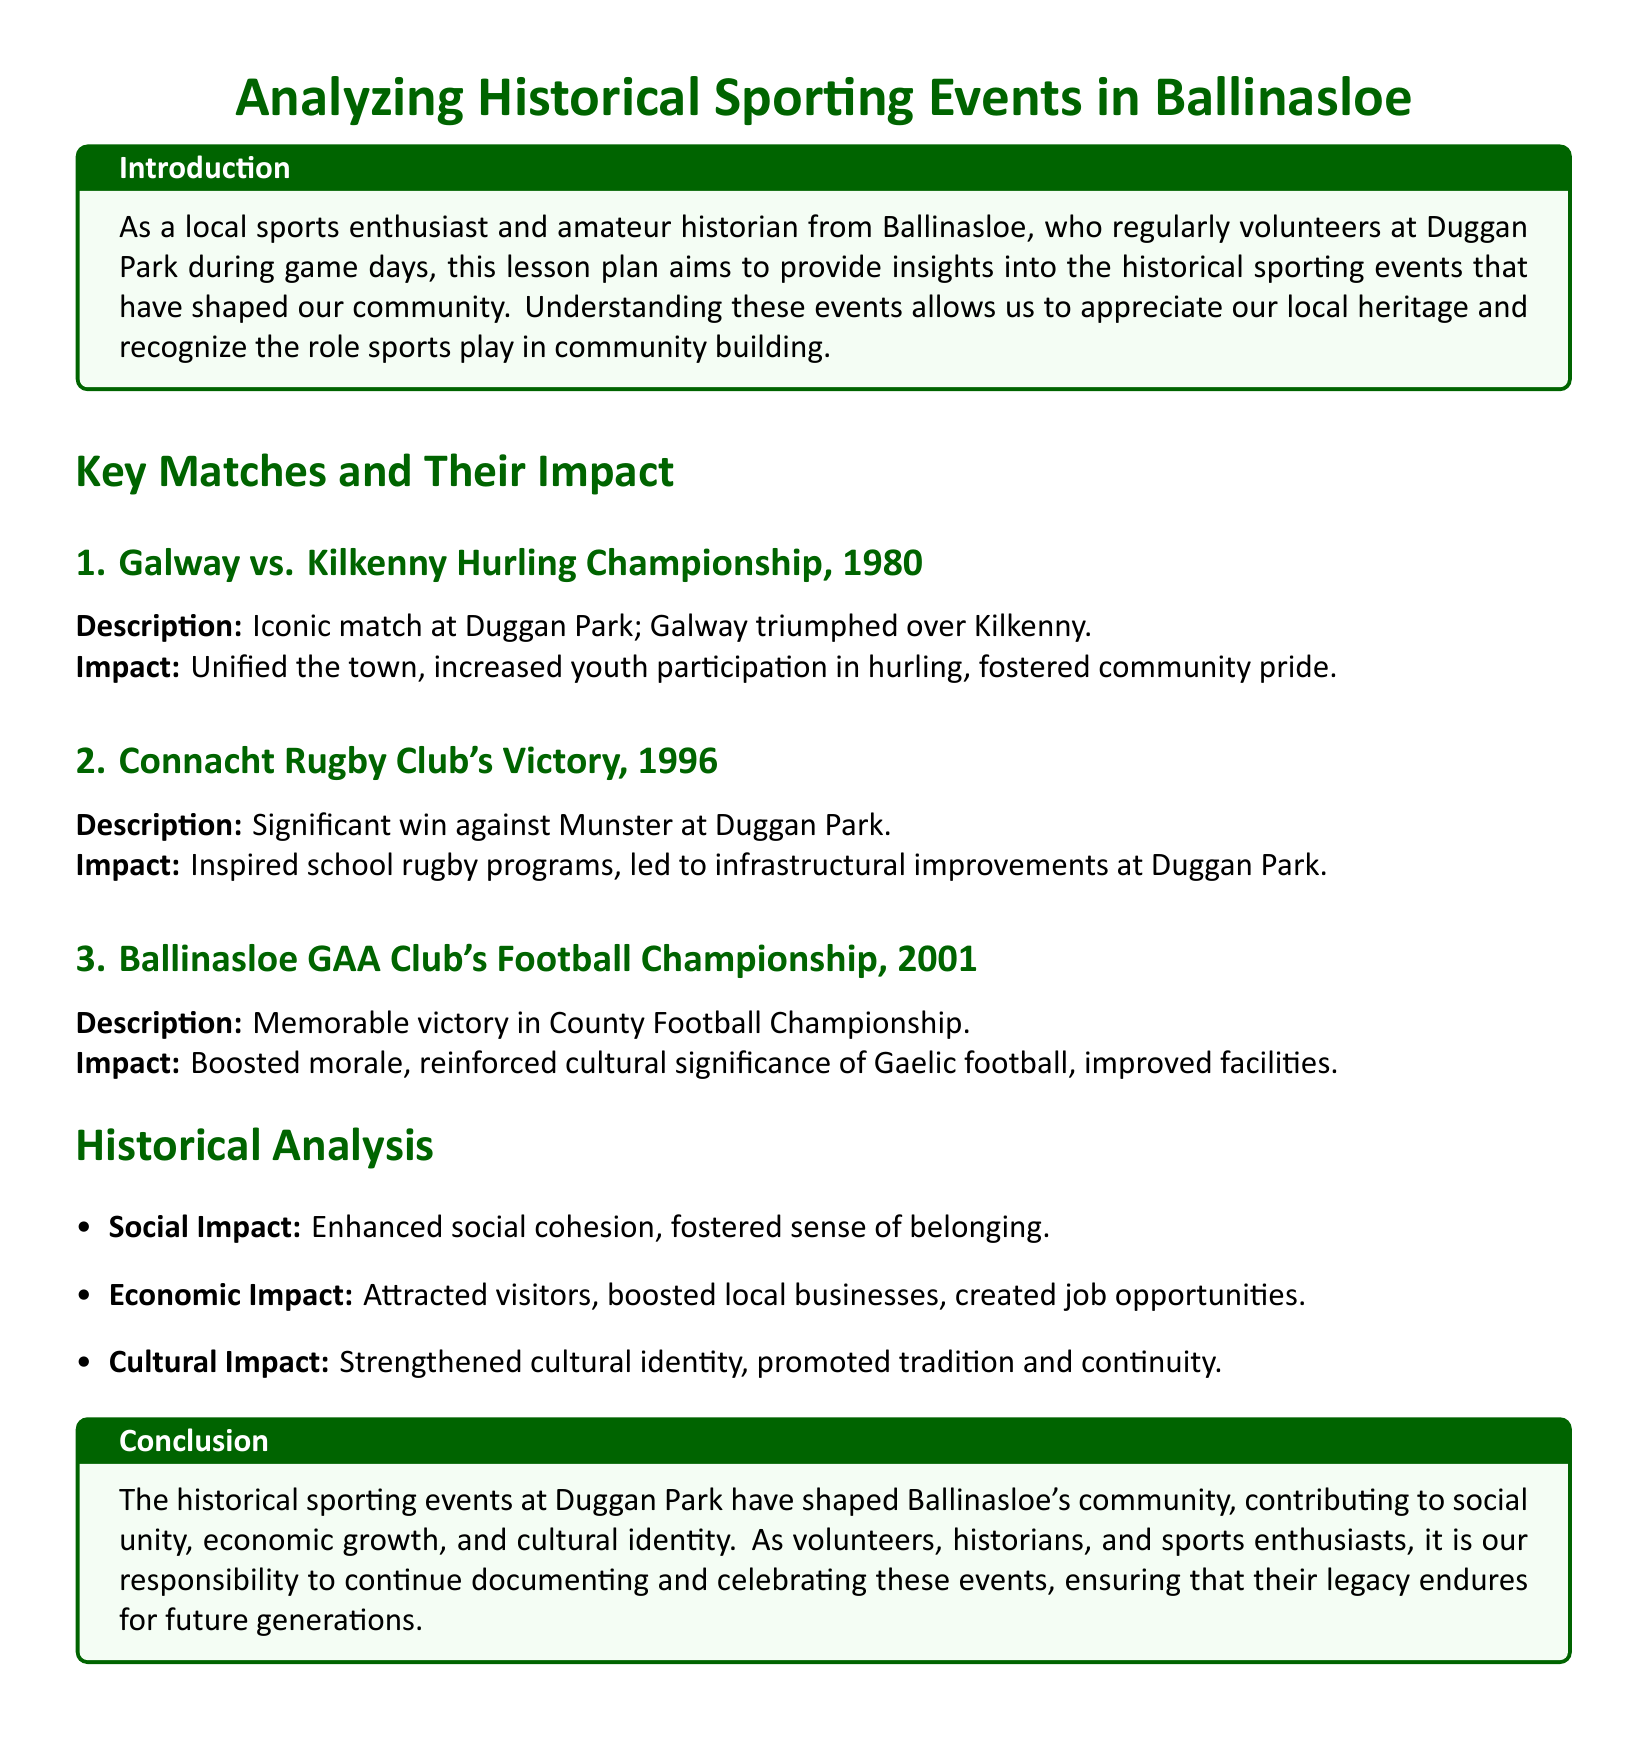What year did Galway play against Kilkenny? The document states that the match took place in 1980.
Answer: 1980 What significant rugby victory occurred in 1996? The lesson plan mentions the Connacht Rugby Club's victory against Munster.
Answer: Connacht Rugby Club's victory What was the notable impact of the 1980 match? The document highlights that the match unified the town and increased youth participation in hurling.
Answer: Unified the town In what year did Ballinasloe GAA Club win the County Football Championship? The document specifies that this victory occurred in 2001.
Answer: 2001 What is one social impact of historical sporting events mentioned? The document notes that events enhanced social cohesion.
Answer: Enhanced social cohesion What type of impacts are analyzed in the lesson plan? The lesson plan discusses social, economic, and cultural impacts.
Answer: Social, economic, cultural What is the key focus of the document? The lesson plan aims to provide insights into historical sporting events in Ballinasloe and their community impact.
Answer: Analyzing Historical Sporting Events What local facility is mentioned as a venue for several key matches? The document states that Duggan Park is the venue for the key matches discussed.
Answer: Duggan Park 